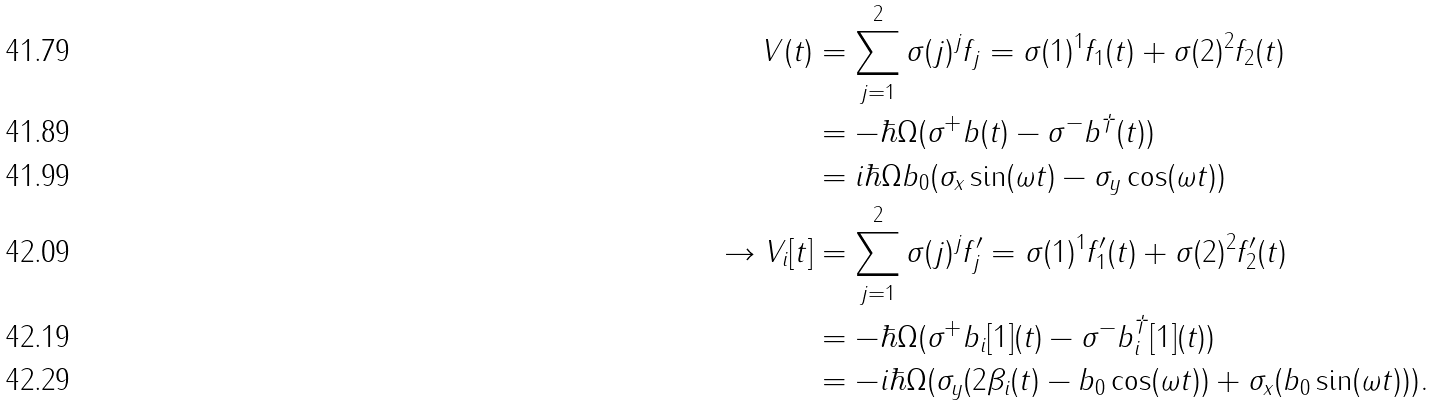<formula> <loc_0><loc_0><loc_500><loc_500>V ( t ) & = \sum _ { j = 1 } ^ { 2 } \sigma ( j ) ^ { j } f _ { j } = \sigma ( 1 ) ^ { 1 } f _ { 1 } ( t ) + \sigma ( 2 ) ^ { 2 } f _ { 2 } ( t ) \\ & = - \hbar { \Omega } ( \sigma ^ { + } b ( t ) - \sigma ^ { - } b ^ { \dagger } ( t ) ) \\ & = i \hbar { \Omega } b _ { 0 } ( \sigma _ { x } \sin ( \omega t ) - \sigma _ { y } \cos ( \omega t ) ) \\ \rightarrow V _ { i } [ t ] & = \sum _ { j = 1 } ^ { 2 } \sigma ( j ) ^ { j } f ^ { \prime } _ { j } = \sigma ( 1 ) ^ { 1 } f ^ { \prime } _ { 1 } ( t ) + \sigma ( 2 ) ^ { 2 } f ^ { \prime } _ { 2 } ( t ) \\ & = - \hbar { \Omega } ( \sigma ^ { + } b _ { i } [ 1 ] ( t ) - \sigma ^ { - } b _ { i } ^ { \dagger } [ 1 ] ( t ) ) \\ & = - i \hbar { \Omega } ( \sigma _ { y } ( 2 \beta _ { i } ( t ) - b _ { 0 } \cos ( \omega t ) ) + \sigma _ { x } ( b _ { 0 } \sin ( \omega t ) ) ) .</formula> 